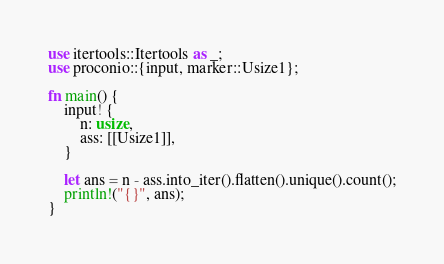<code> <loc_0><loc_0><loc_500><loc_500><_Rust_>use itertools::Itertools as _;
use proconio::{input, marker::Usize1};

fn main() {
    input! {
        n: usize,
        ass: [[Usize1]],
    }

    let ans = n - ass.into_iter().flatten().unique().count();
    println!("{}", ans);
}
</code> 